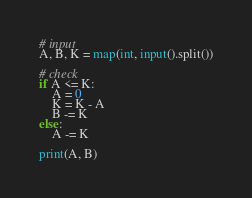<code> <loc_0><loc_0><loc_500><loc_500><_Python_># input
A, B, K = map(int, input().split())

# check
if A <= K:
    A = 0
    K = K - A
    B -= K
else:
    A -= K

print(A, B)
</code> 